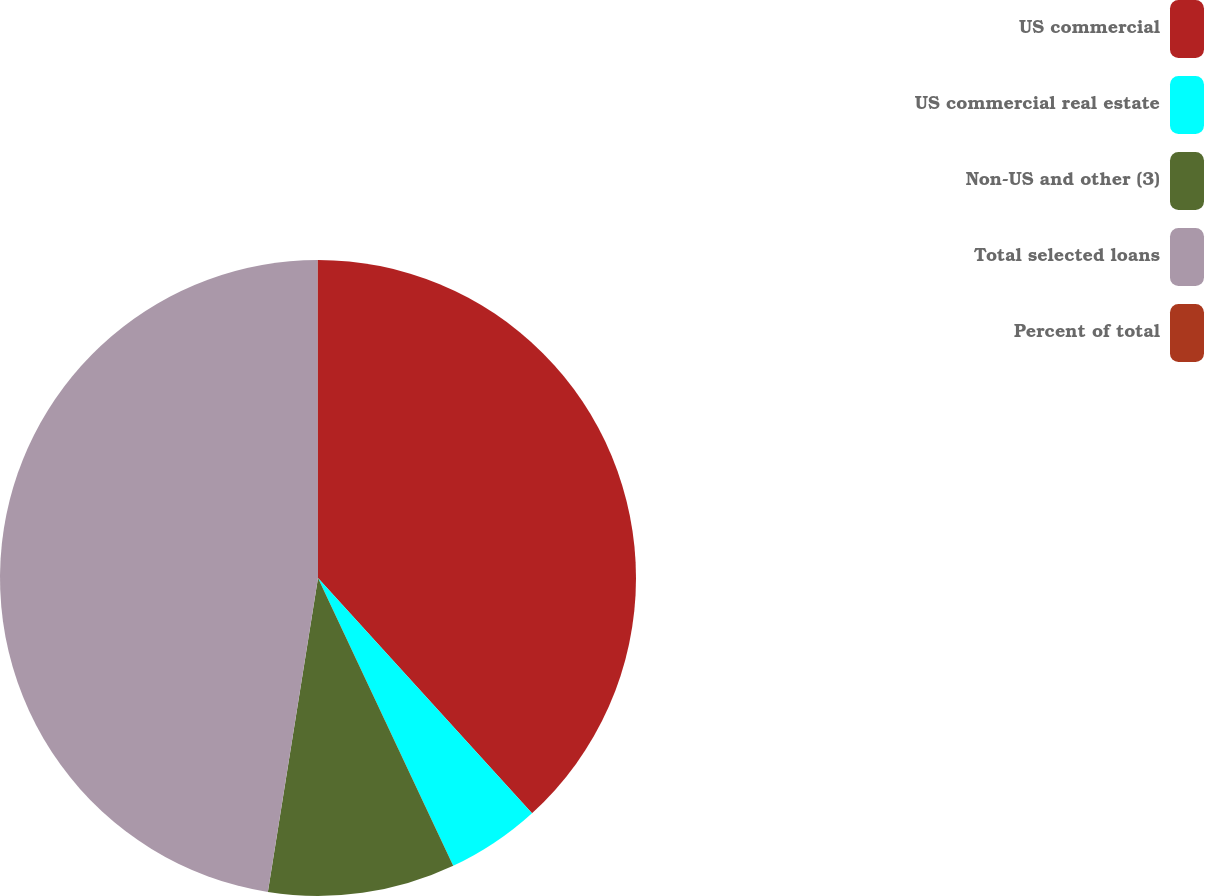Convert chart. <chart><loc_0><loc_0><loc_500><loc_500><pie_chart><fcel>US commercial<fcel>US commercial real estate<fcel>Non-US and other (3)<fcel>Total selected loans<fcel>Percent of total<nl><fcel>38.25%<fcel>4.76%<fcel>9.51%<fcel>47.47%<fcel>0.01%<nl></chart> 